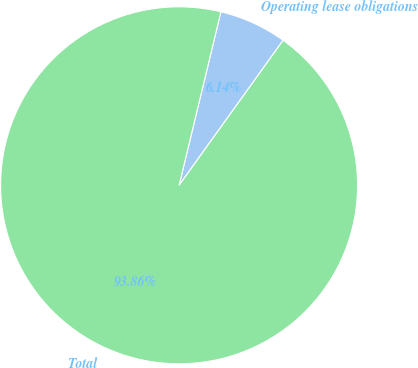Convert chart to OTSL. <chart><loc_0><loc_0><loc_500><loc_500><pie_chart><fcel>Operating lease obligations<fcel>Total<nl><fcel>6.14%<fcel>93.86%<nl></chart> 